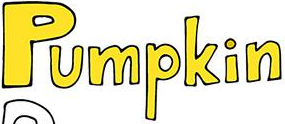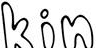What text appears in these images from left to right, separated by a semicolon? Pumpkin; kin 